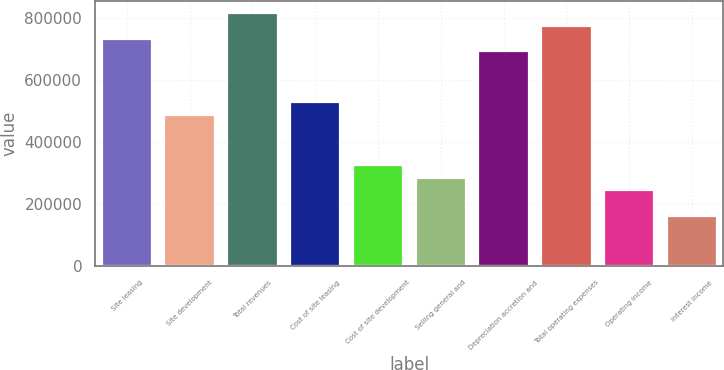<chart> <loc_0><loc_0><loc_500><loc_500><bar_chart><fcel>Site leasing<fcel>Site development<fcel>Total revenues<fcel>Cost of site leasing<fcel>Cost of site development<fcel>Selling general and<fcel>Depreciation accretion and<fcel>Total operating expenses<fcel>Operating income<fcel>Interest income<nl><fcel>734761<fcel>489841<fcel>816401<fcel>530661<fcel>326561<fcel>285741<fcel>693941<fcel>775581<fcel>244921<fcel>163281<nl></chart> 